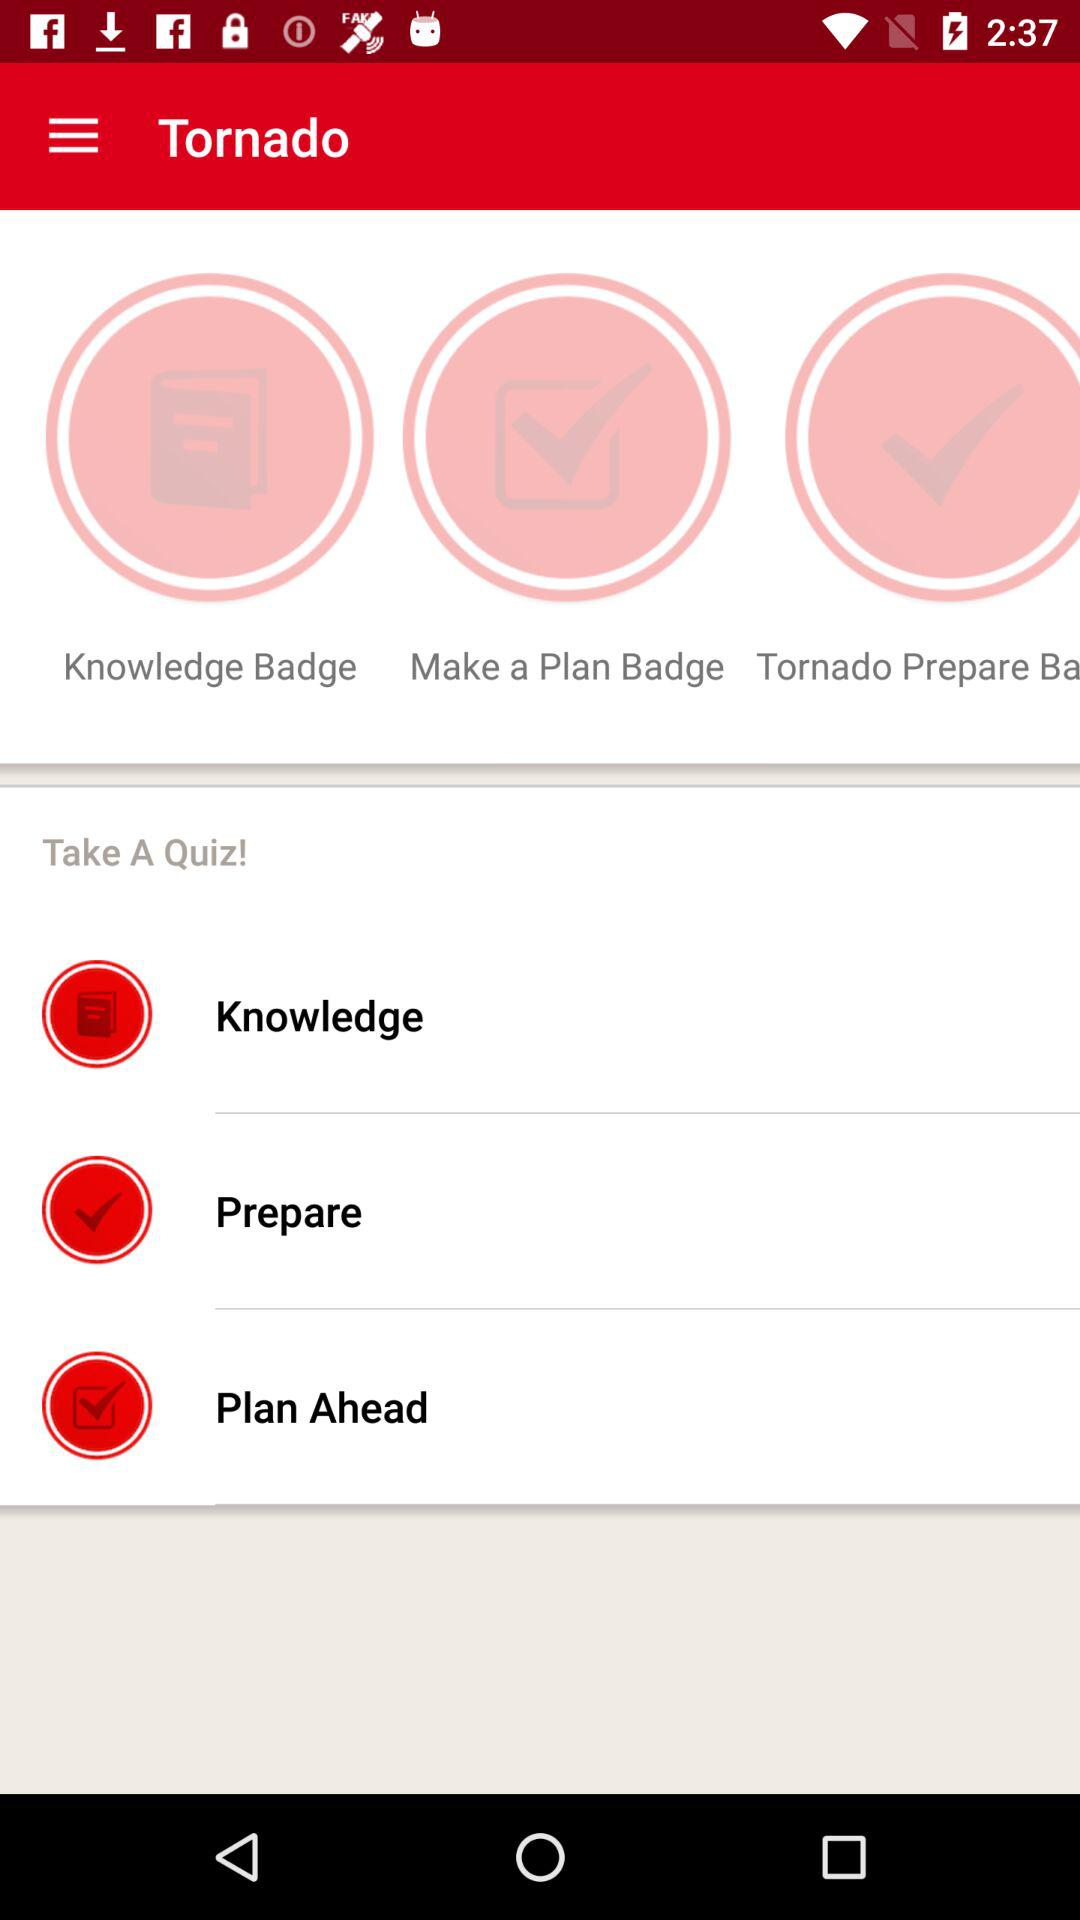How many badges are there for Tornado?
Answer the question using a single word or phrase. 3 